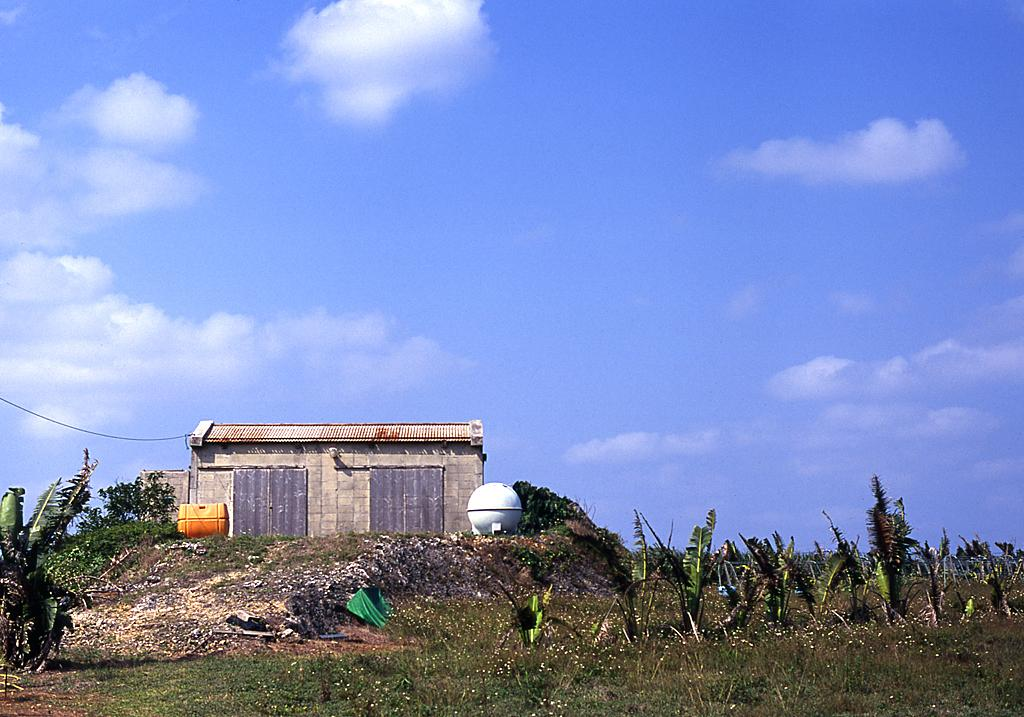What type of vegetation is at the bottom of the image? There are trees at the bottom of the image. What structure is located in the middle of the image? There is a house in the middle of the image. What is visible at the top of the image? The sky is visible at the top of the image. Can you tell me how many geese are depicted in the image? There are no geese present in the image; it features trees, a house, and the sky. What type of tool is being used to build the house in the image? There is no tool being used to build the house in the image; it is already constructed. 